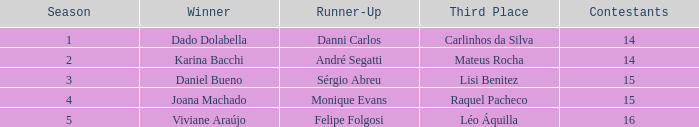What was the number of competitors when monique evans finished as the runner-up? 15.0. 